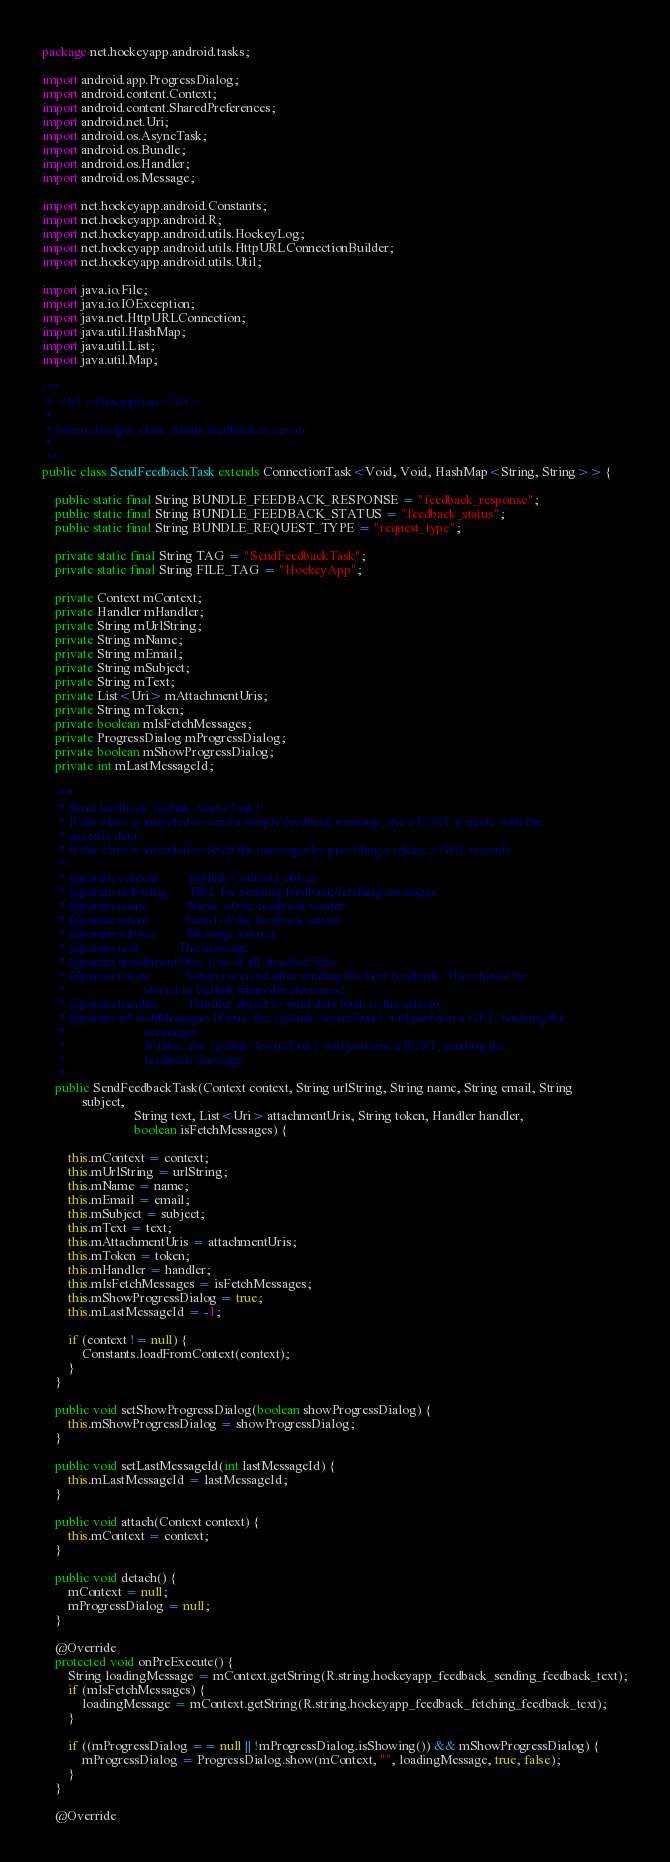Convert code to text. <code><loc_0><loc_0><loc_500><loc_500><_Java_>package net.hockeyapp.android.tasks;

import android.app.ProgressDialog;
import android.content.Context;
import android.content.SharedPreferences;
import android.net.Uri;
import android.os.AsyncTask;
import android.os.Bundle;
import android.os.Handler;
import android.os.Message;

import net.hockeyapp.android.Constants;
import net.hockeyapp.android.R;
import net.hockeyapp.android.utils.HockeyLog;
import net.hockeyapp.android.utils.HttpURLConnectionBuilder;
import net.hockeyapp.android.utils.Util;

import java.io.File;
import java.io.IOException;
import java.net.HttpURLConnection;
import java.util.HashMap;
import java.util.List;
import java.util.Map;

/**
 * <h3>Description</h3>
 *
 * Internal helper class. Sends feedback to server.
 *
 **/
public class SendFeedbackTask extends ConnectionTask<Void, Void, HashMap<String, String>> {

    public static final String BUNDLE_FEEDBACK_RESPONSE = "feedback_response";
    public static final String BUNDLE_FEEDBACK_STATUS = "feedback_status";
    public static final String BUNDLE_REQUEST_TYPE = "request_type";

    private static final String TAG = "SendFeedbackTask";
    private static final String FILE_TAG = "HockeyApp";

    private Context mContext;
    private Handler mHandler;
    private String mUrlString;
    private String mName;
    private String mEmail;
    private String mSubject;
    private String mText;
    private List<Uri> mAttachmentUris;
    private String mToken;
    private boolean mIsFetchMessages;
    private ProgressDialog mProgressDialog;
    private boolean mShowProgressDialog;
    private int mLastMessageId;

    /**
     * Send feedback {@link AsyncTask}.
     * If the class is intended to send a simple feedback message, the a POST is made with the
     * specific data
     * If the class is intended to fetch the messages by providing a token, a GET is made
     *
     * @param context         {@link Context} object
     * @param urlString       URL for sending feedback/fetching messages
     * @param name            Name of the feedback sender
     * @param email           Email of the feedback sender
     * @param subject         Message subject
     * @param text            The message
     * @param attachmentUris  List of all attached files
     * @param token           Token received after sending the first feedback. This should be
     *                        stored in {@link SharedPreferences}
     * @param handler         Handler object to send data back to the activity
     * @param isFetchMessages If true, the {@link AsyncTask} will perform a GET, fetching the
     *                        messages.
     *                        If false, the {@link AsyncTask} will perform a POST, sending the
     *                        feedback message
     */
    public SendFeedbackTask(Context context, String urlString, String name, String email, String
            subject,
                            String text, List<Uri> attachmentUris, String token, Handler handler,
                            boolean isFetchMessages) {

        this.mContext = context;
        this.mUrlString = urlString;
        this.mName = name;
        this.mEmail = email;
        this.mSubject = subject;
        this.mText = text;
        this.mAttachmentUris = attachmentUris;
        this.mToken = token;
        this.mHandler = handler;
        this.mIsFetchMessages = isFetchMessages;
        this.mShowProgressDialog = true;
        this.mLastMessageId = -1;

        if (context != null) {
            Constants.loadFromContext(context);
        }
    }

    public void setShowProgressDialog(boolean showProgressDialog) {
        this.mShowProgressDialog = showProgressDialog;
    }

    public void setLastMessageId(int lastMessageId) {
        this.mLastMessageId = lastMessageId;
    }

    public void attach(Context context) {
        this.mContext = context;
    }

    public void detach() {
        mContext = null;
        mProgressDialog = null;
    }

    @Override
    protected void onPreExecute() {
        String loadingMessage = mContext.getString(R.string.hockeyapp_feedback_sending_feedback_text);
        if (mIsFetchMessages) {
            loadingMessage = mContext.getString(R.string.hockeyapp_feedback_fetching_feedback_text);
        }

        if ((mProgressDialog == null || !mProgressDialog.isShowing()) && mShowProgressDialog) {
            mProgressDialog = ProgressDialog.show(mContext, "", loadingMessage, true, false);
        }
    }

    @Override</code> 